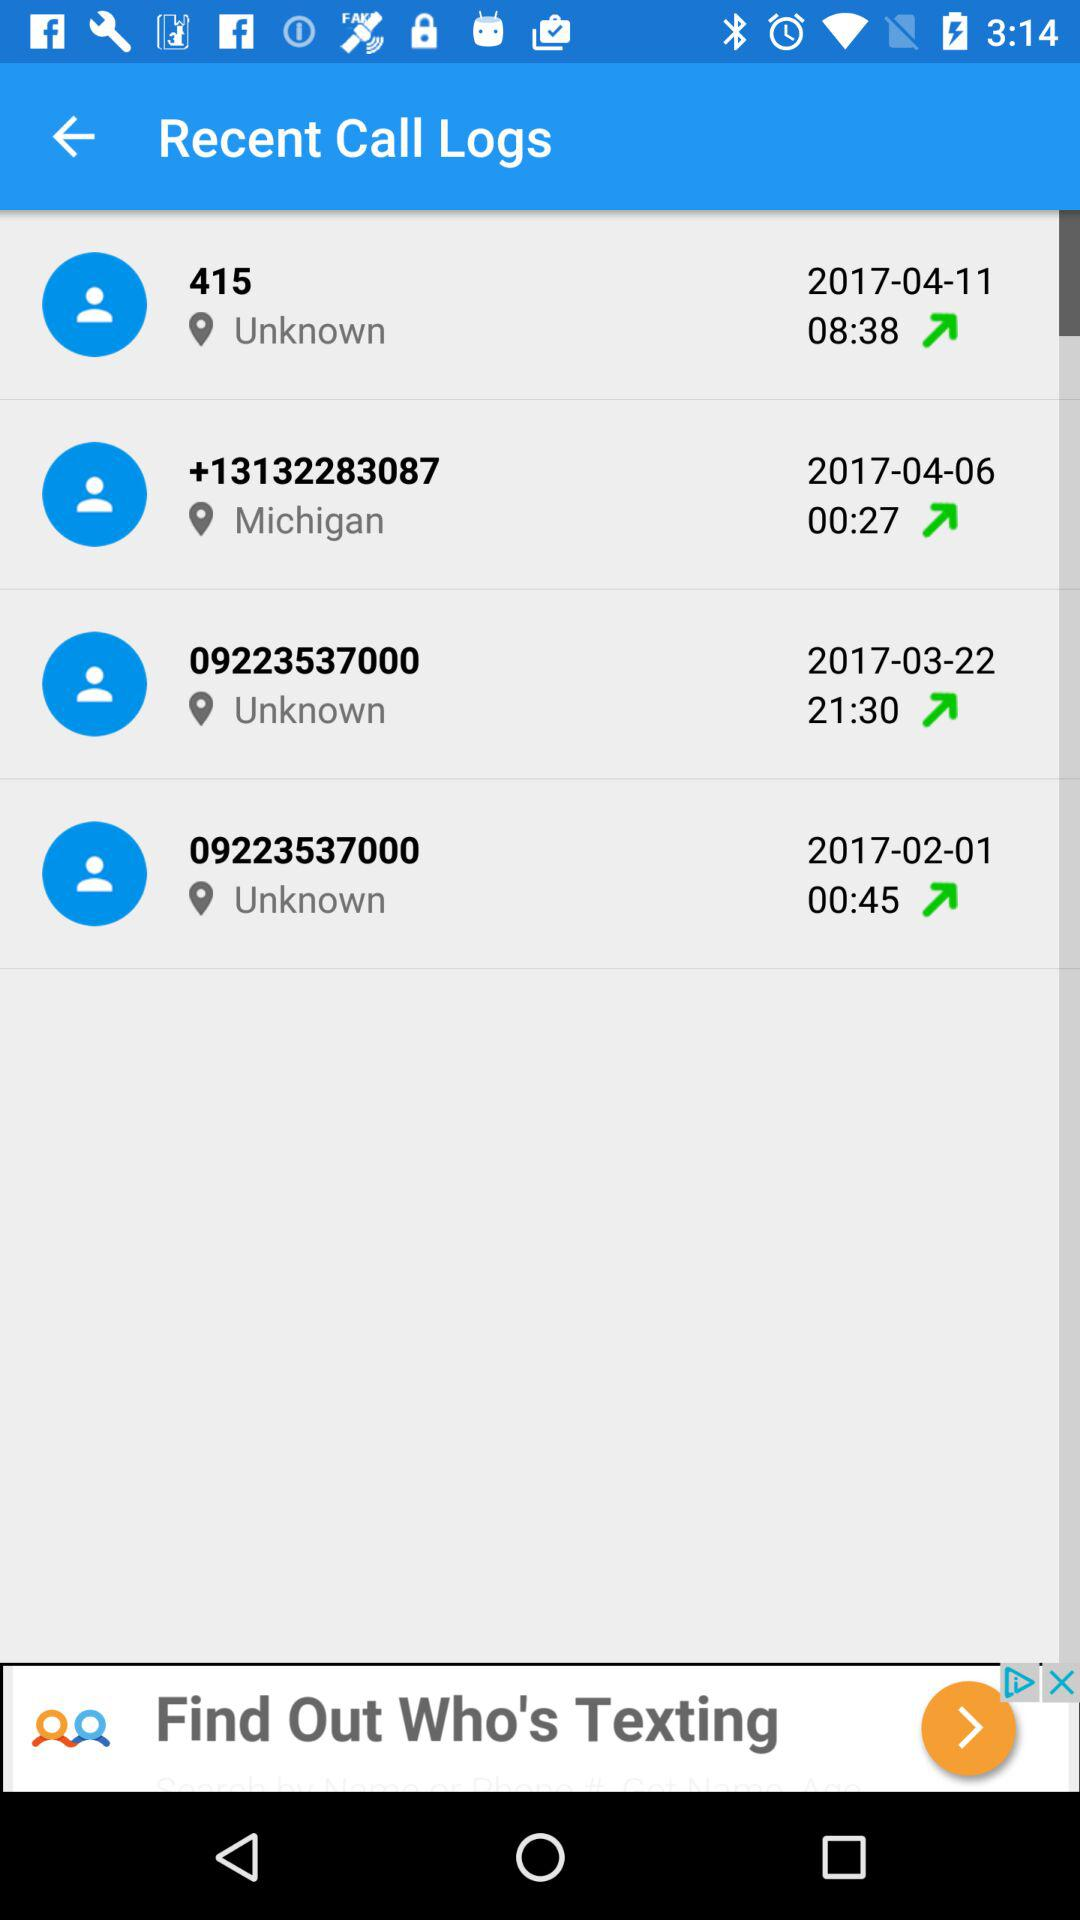What's the total duration of the call with 415? The total duration of the call with 415 is 8 minutes 38 seconds. 